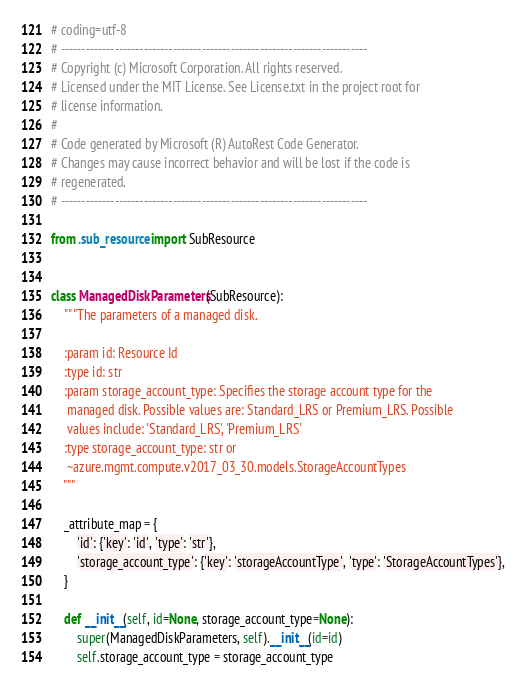<code> <loc_0><loc_0><loc_500><loc_500><_Python_># coding=utf-8
# --------------------------------------------------------------------------
# Copyright (c) Microsoft Corporation. All rights reserved.
# Licensed under the MIT License. See License.txt in the project root for
# license information.
#
# Code generated by Microsoft (R) AutoRest Code Generator.
# Changes may cause incorrect behavior and will be lost if the code is
# regenerated.
# --------------------------------------------------------------------------

from .sub_resource import SubResource


class ManagedDiskParameters(SubResource):
    """The parameters of a managed disk.

    :param id: Resource Id
    :type id: str
    :param storage_account_type: Specifies the storage account type for the
     managed disk. Possible values are: Standard_LRS or Premium_LRS. Possible
     values include: 'Standard_LRS', 'Premium_LRS'
    :type storage_account_type: str or
     ~azure.mgmt.compute.v2017_03_30.models.StorageAccountTypes
    """

    _attribute_map = {
        'id': {'key': 'id', 'type': 'str'},
        'storage_account_type': {'key': 'storageAccountType', 'type': 'StorageAccountTypes'},
    }

    def __init__(self, id=None, storage_account_type=None):
        super(ManagedDiskParameters, self).__init__(id=id)
        self.storage_account_type = storage_account_type
</code> 